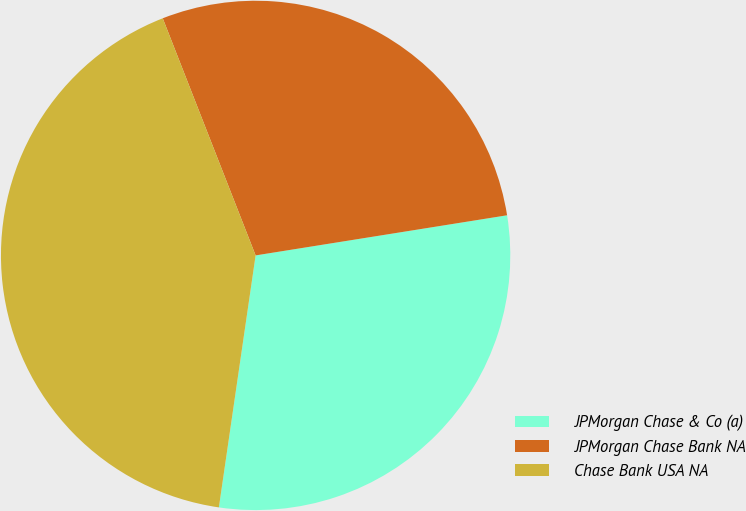Convert chart to OTSL. <chart><loc_0><loc_0><loc_500><loc_500><pie_chart><fcel>JPMorgan Chase & Co (a)<fcel>JPMorgan Chase Bank NA<fcel>Chase Bank USA NA<nl><fcel>29.82%<fcel>28.42%<fcel>41.75%<nl></chart> 